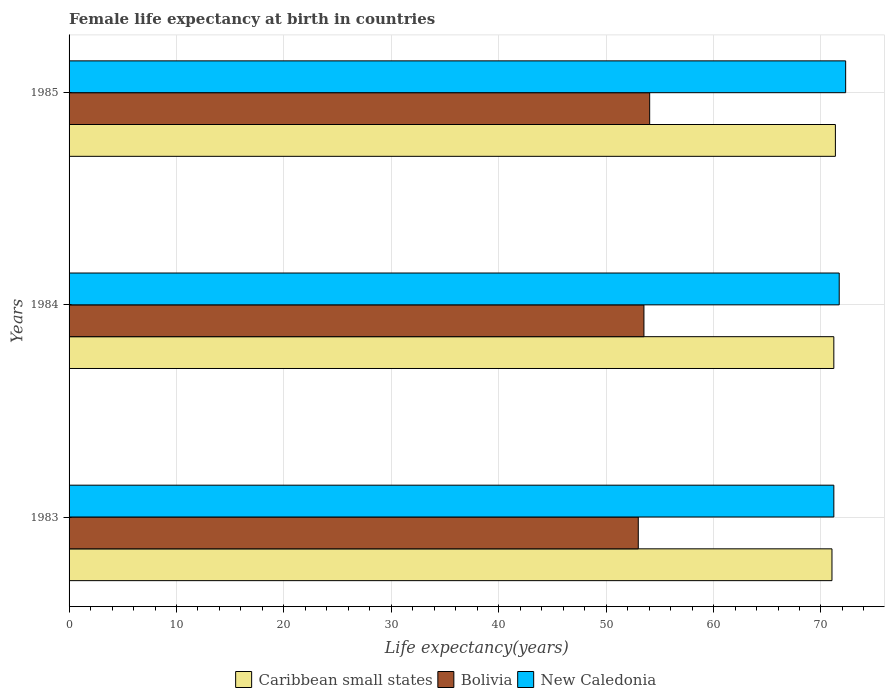Are the number of bars on each tick of the Y-axis equal?
Offer a terse response. Yes. How many bars are there on the 1st tick from the top?
Your answer should be very brief. 3. How many bars are there on the 3rd tick from the bottom?
Keep it short and to the point. 3. What is the label of the 3rd group of bars from the top?
Keep it short and to the point. 1983. In how many cases, is the number of bars for a given year not equal to the number of legend labels?
Offer a very short reply. 0. What is the female life expectancy at birth in Bolivia in 1984?
Offer a terse response. 53.52. Across all years, what is the maximum female life expectancy at birth in New Caledonia?
Your answer should be very brief. 72.3. Across all years, what is the minimum female life expectancy at birth in Bolivia?
Keep it short and to the point. 52.99. In which year was the female life expectancy at birth in Bolivia maximum?
Keep it short and to the point. 1985. In which year was the female life expectancy at birth in Bolivia minimum?
Your response must be concise. 1983. What is the total female life expectancy at birth in Caribbean small states in the graph?
Give a very brief answer. 213.57. What is the difference between the female life expectancy at birth in Caribbean small states in 1983 and that in 1984?
Provide a short and direct response. -0.17. What is the difference between the female life expectancy at birth in Bolivia in 1985 and the female life expectancy at birth in Caribbean small states in 1984?
Give a very brief answer. -17.14. What is the average female life expectancy at birth in Caribbean small states per year?
Make the answer very short. 71.19. In the year 1983, what is the difference between the female life expectancy at birth in Bolivia and female life expectancy at birth in New Caledonia?
Your answer should be compact. -18.21. In how many years, is the female life expectancy at birth in New Caledonia greater than 50 years?
Make the answer very short. 3. What is the ratio of the female life expectancy at birth in Bolivia in 1983 to that in 1984?
Provide a succinct answer. 0.99. Is the difference between the female life expectancy at birth in Bolivia in 1983 and 1985 greater than the difference between the female life expectancy at birth in New Caledonia in 1983 and 1985?
Your response must be concise. Yes. What is the difference between the highest and the second highest female life expectancy at birth in Caribbean small states?
Offer a very short reply. 0.15. What is the difference between the highest and the lowest female life expectancy at birth in Bolivia?
Offer a terse response. 1.06. What does the 2nd bar from the top in 1985 represents?
Offer a very short reply. Bolivia. What does the 2nd bar from the bottom in 1983 represents?
Provide a short and direct response. Bolivia. Is it the case that in every year, the sum of the female life expectancy at birth in New Caledonia and female life expectancy at birth in Caribbean small states is greater than the female life expectancy at birth in Bolivia?
Keep it short and to the point. Yes. How many bars are there?
Ensure brevity in your answer.  9. Are all the bars in the graph horizontal?
Provide a succinct answer. Yes. How many years are there in the graph?
Offer a very short reply. 3. What is the difference between two consecutive major ticks on the X-axis?
Give a very brief answer. 10. Are the values on the major ticks of X-axis written in scientific E-notation?
Your response must be concise. No. Does the graph contain any zero values?
Your response must be concise. No. Where does the legend appear in the graph?
Give a very brief answer. Bottom center. How many legend labels are there?
Your answer should be compact. 3. What is the title of the graph?
Provide a succinct answer. Female life expectancy at birth in countries. Does "Chad" appear as one of the legend labels in the graph?
Ensure brevity in your answer.  No. What is the label or title of the X-axis?
Your response must be concise. Life expectancy(years). What is the Life expectancy(years) of Caribbean small states in 1983?
Your answer should be compact. 71.02. What is the Life expectancy(years) in Bolivia in 1983?
Your response must be concise. 52.99. What is the Life expectancy(years) in New Caledonia in 1983?
Provide a short and direct response. 71.2. What is the Life expectancy(years) of Caribbean small states in 1984?
Give a very brief answer. 71.2. What is the Life expectancy(years) of Bolivia in 1984?
Provide a short and direct response. 53.52. What is the Life expectancy(years) of New Caledonia in 1984?
Offer a very short reply. 71.7. What is the Life expectancy(years) in Caribbean small states in 1985?
Make the answer very short. 71.34. What is the Life expectancy(years) of Bolivia in 1985?
Offer a very short reply. 54.05. What is the Life expectancy(years) in New Caledonia in 1985?
Your answer should be very brief. 72.3. Across all years, what is the maximum Life expectancy(years) of Caribbean small states?
Keep it short and to the point. 71.34. Across all years, what is the maximum Life expectancy(years) in Bolivia?
Your answer should be compact. 54.05. Across all years, what is the maximum Life expectancy(years) of New Caledonia?
Offer a terse response. 72.3. Across all years, what is the minimum Life expectancy(years) in Caribbean small states?
Give a very brief answer. 71.02. Across all years, what is the minimum Life expectancy(years) in Bolivia?
Give a very brief answer. 52.99. Across all years, what is the minimum Life expectancy(years) of New Caledonia?
Provide a short and direct response. 71.2. What is the total Life expectancy(years) in Caribbean small states in the graph?
Give a very brief answer. 213.57. What is the total Life expectancy(years) of Bolivia in the graph?
Keep it short and to the point. 160.57. What is the total Life expectancy(years) of New Caledonia in the graph?
Give a very brief answer. 215.2. What is the difference between the Life expectancy(years) of Caribbean small states in 1983 and that in 1984?
Your response must be concise. -0.17. What is the difference between the Life expectancy(years) in Bolivia in 1983 and that in 1984?
Provide a succinct answer. -0.53. What is the difference between the Life expectancy(years) in Caribbean small states in 1983 and that in 1985?
Make the answer very short. -0.32. What is the difference between the Life expectancy(years) in Bolivia in 1983 and that in 1985?
Make the answer very short. -1.06. What is the difference between the Life expectancy(years) in Caribbean small states in 1984 and that in 1985?
Provide a short and direct response. -0.15. What is the difference between the Life expectancy(years) of Bolivia in 1984 and that in 1985?
Your answer should be very brief. -0.53. What is the difference between the Life expectancy(years) of Caribbean small states in 1983 and the Life expectancy(years) of Bolivia in 1984?
Keep it short and to the point. 17.5. What is the difference between the Life expectancy(years) in Caribbean small states in 1983 and the Life expectancy(years) in New Caledonia in 1984?
Provide a short and direct response. -0.68. What is the difference between the Life expectancy(years) in Bolivia in 1983 and the Life expectancy(years) in New Caledonia in 1984?
Provide a short and direct response. -18.71. What is the difference between the Life expectancy(years) of Caribbean small states in 1983 and the Life expectancy(years) of Bolivia in 1985?
Provide a succinct answer. 16.97. What is the difference between the Life expectancy(years) of Caribbean small states in 1983 and the Life expectancy(years) of New Caledonia in 1985?
Make the answer very short. -1.28. What is the difference between the Life expectancy(years) of Bolivia in 1983 and the Life expectancy(years) of New Caledonia in 1985?
Your response must be concise. -19.31. What is the difference between the Life expectancy(years) in Caribbean small states in 1984 and the Life expectancy(years) in Bolivia in 1985?
Give a very brief answer. 17.14. What is the difference between the Life expectancy(years) of Caribbean small states in 1984 and the Life expectancy(years) of New Caledonia in 1985?
Ensure brevity in your answer.  -1.1. What is the difference between the Life expectancy(years) of Bolivia in 1984 and the Life expectancy(years) of New Caledonia in 1985?
Offer a very short reply. -18.78. What is the average Life expectancy(years) in Caribbean small states per year?
Your answer should be compact. 71.19. What is the average Life expectancy(years) of Bolivia per year?
Provide a short and direct response. 53.52. What is the average Life expectancy(years) in New Caledonia per year?
Make the answer very short. 71.73. In the year 1983, what is the difference between the Life expectancy(years) in Caribbean small states and Life expectancy(years) in Bolivia?
Your answer should be very brief. 18.03. In the year 1983, what is the difference between the Life expectancy(years) of Caribbean small states and Life expectancy(years) of New Caledonia?
Offer a terse response. -0.18. In the year 1983, what is the difference between the Life expectancy(years) in Bolivia and Life expectancy(years) in New Caledonia?
Your answer should be compact. -18.21. In the year 1984, what is the difference between the Life expectancy(years) in Caribbean small states and Life expectancy(years) in Bolivia?
Your answer should be very brief. 17.68. In the year 1984, what is the difference between the Life expectancy(years) of Caribbean small states and Life expectancy(years) of New Caledonia?
Ensure brevity in your answer.  -0.5. In the year 1984, what is the difference between the Life expectancy(years) in Bolivia and Life expectancy(years) in New Caledonia?
Make the answer very short. -18.18. In the year 1985, what is the difference between the Life expectancy(years) of Caribbean small states and Life expectancy(years) of Bolivia?
Keep it short and to the point. 17.29. In the year 1985, what is the difference between the Life expectancy(years) of Caribbean small states and Life expectancy(years) of New Caledonia?
Your answer should be very brief. -0.96. In the year 1985, what is the difference between the Life expectancy(years) of Bolivia and Life expectancy(years) of New Caledonia?
Your response must be concise. -18.25. What is the ratio of the Life expectancy(years) in Bolivia in 1983 to that in 1984?
Your response must be concise. 0.99. What is the ratio of the Life expectancy(years) of New Caledonia in 1983 to that in 1984?
Keep it short and to the point. 0.99. What is the ratio of the Life expectancy(years) in Bolivia in 1983 to that in 1985?
Offer a terse response. 0.98. What is the ratio of the Life expectancy(years) in New Caledonia in 1983 to that in 1985?
Ensure brevity in your answer.  0.98. What is the ratio of the Life expectancy(years) of New Caledonia in 1984 to that in 1985?
Provide a succinct answer. 0.99. What is the difference between the highest and the second highest Life expectancy(years) of Caribbean small states?
Provide a succinct answer. 0.15. What is the difference between the highest and the second highest Life expectancy(years) of Bolivia?
Make the answer very short. 0.53. What is the difference between the highest and the second highest Life expectancy(years) of New Caledonia?
Give a very brief answer. 0.6. What is the difference between the highest and the lowest Life expectancy(years) in Caribbean small states?
Your response must be concise. 0.32. What is the difference between the highest and the lowest Life expectancy(years) in Bolivia?
Ensure brevity in your answer.  1.06. 